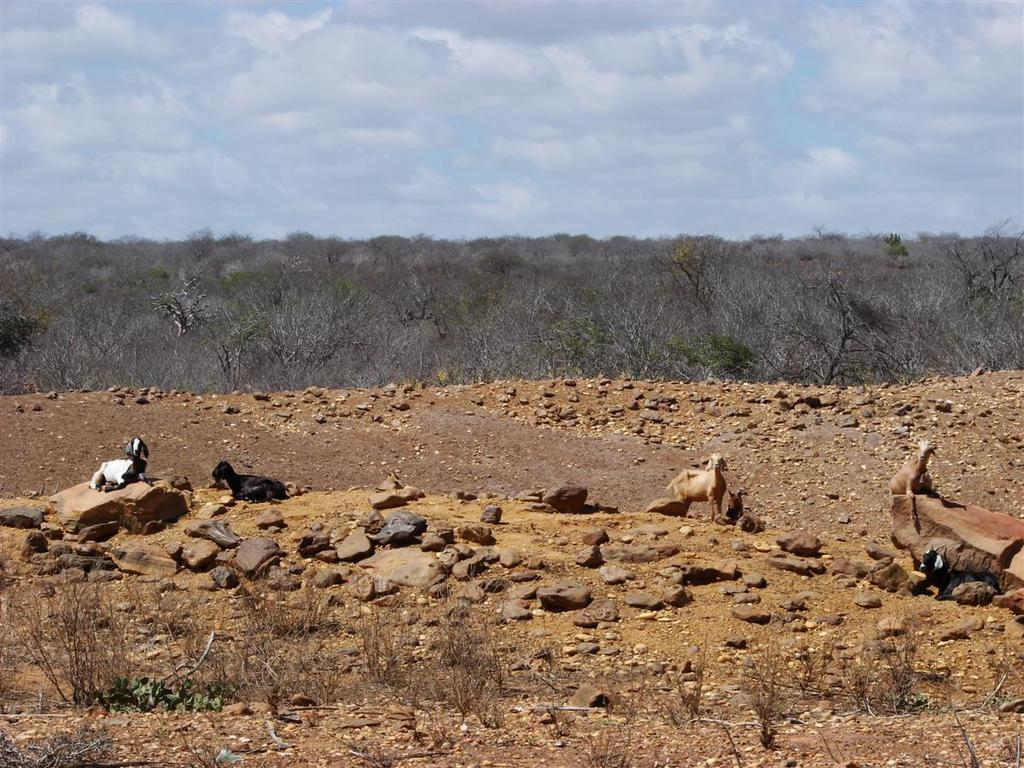What can be seen on the surface in the image? There is a group of animals on the surface in the image. What is present in the foreground of the image? There are plants and rocks in the foreground of the image. What is visible in the background of the image? There is a group of trees and the sky in the background of the image. How would you describe the sky in the image? The sky is cloudy and visible in the background of the image. What is on the list that the animals are regretting in the image? There is no list or indication of regret in the image; it features a group of animals on a surface with plants, rocks, trees, and a cloudy sky in the background. 